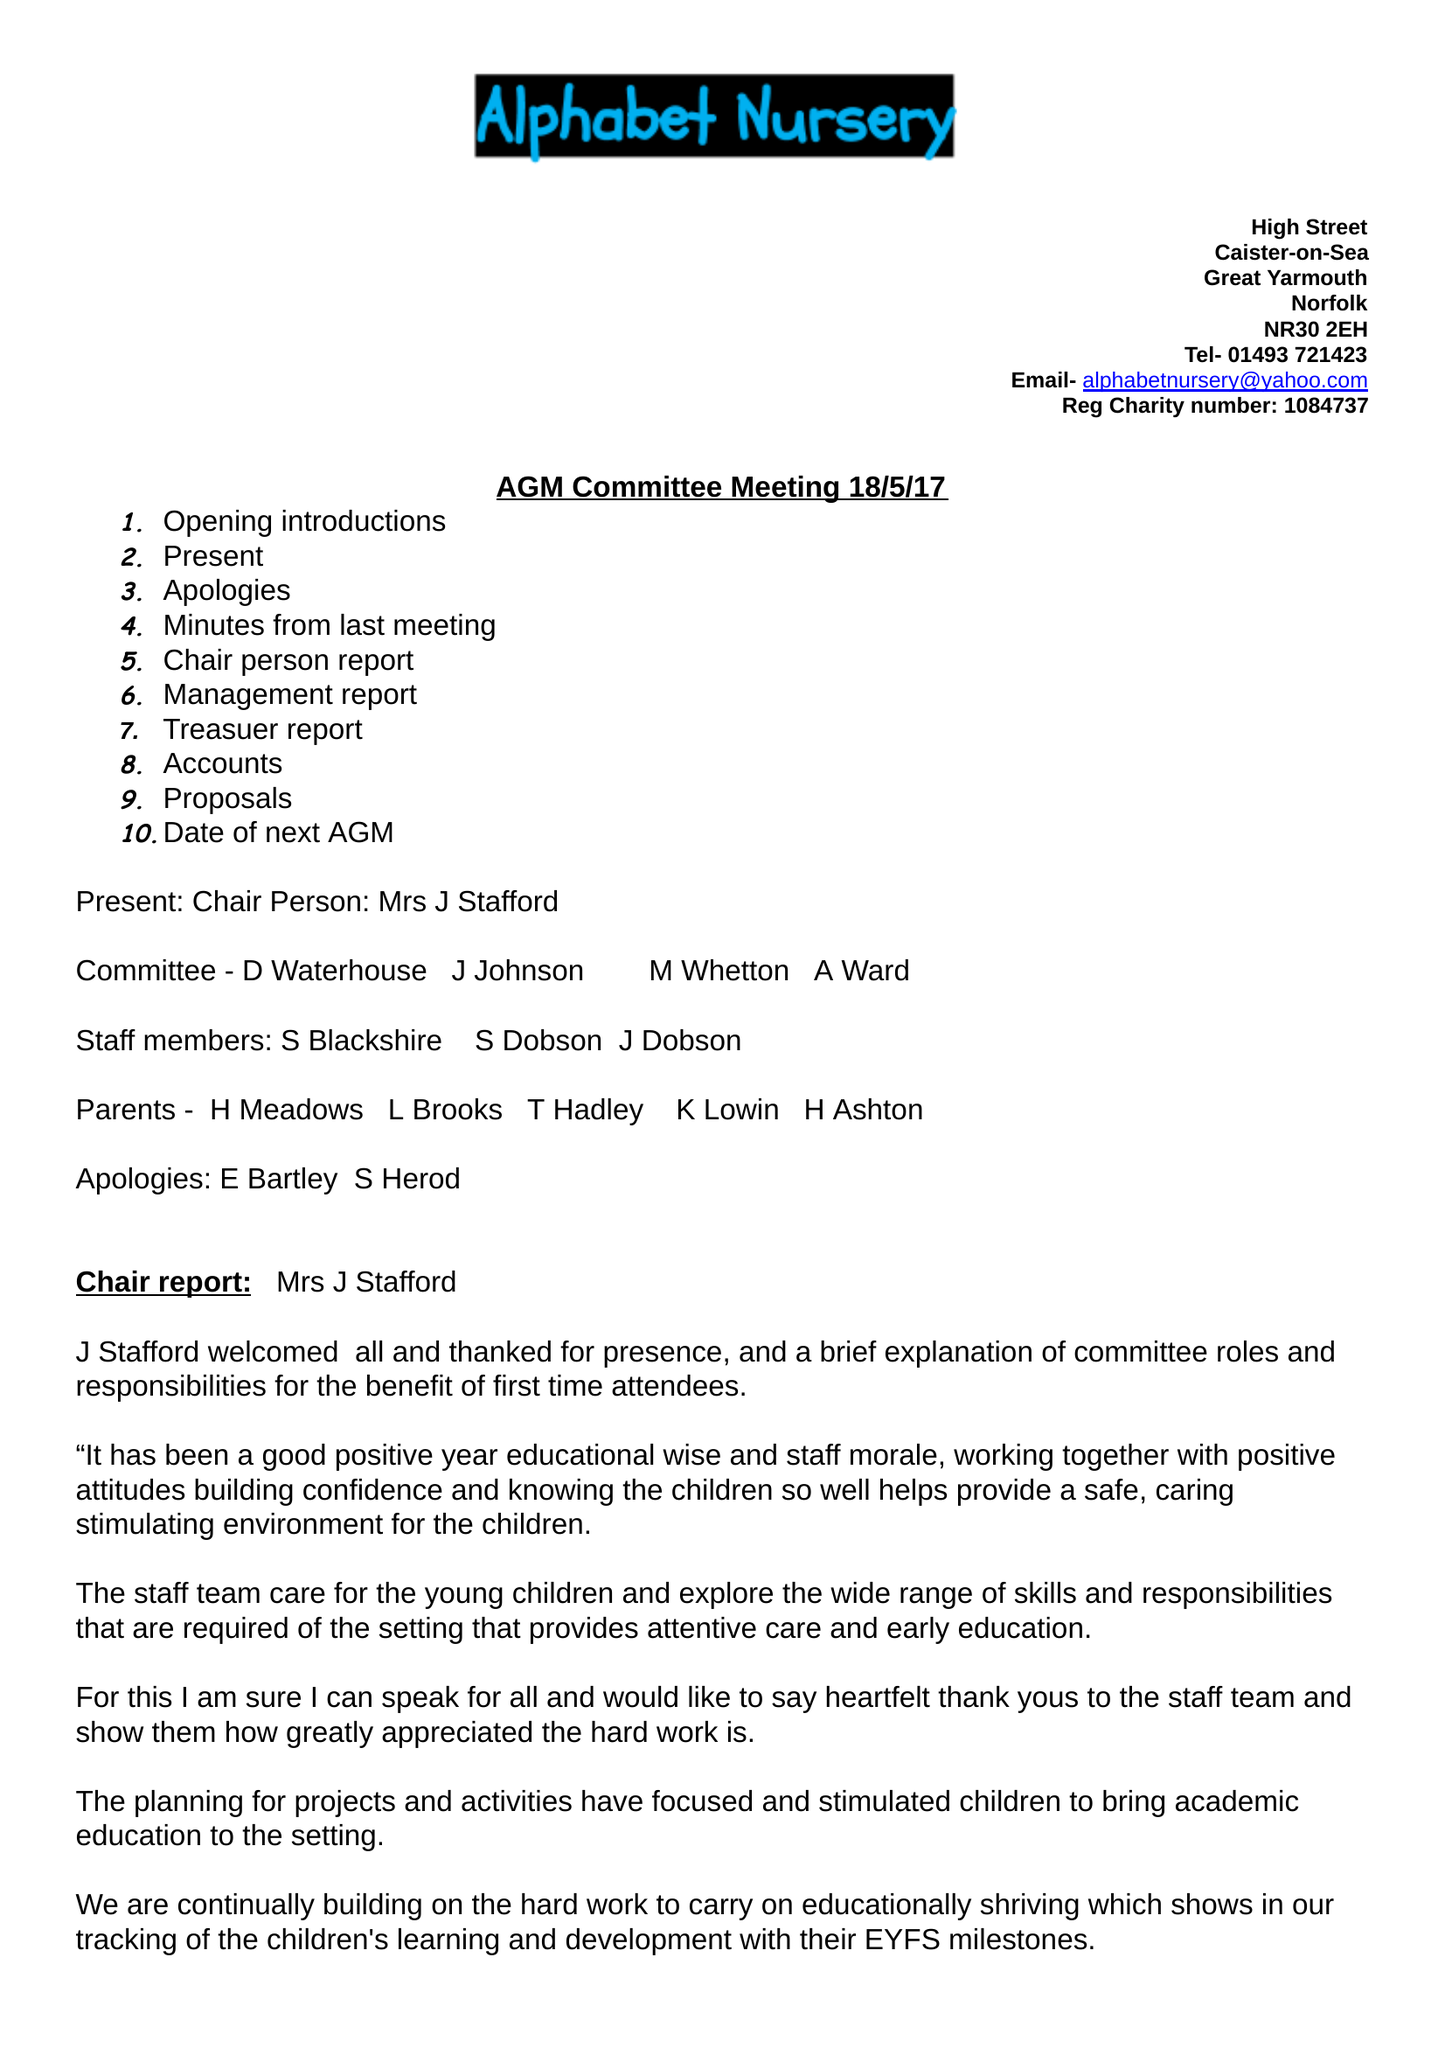What is the value for the address__post_town?
Answer the question using a single word or phrase. GREAT YARMOUTH 